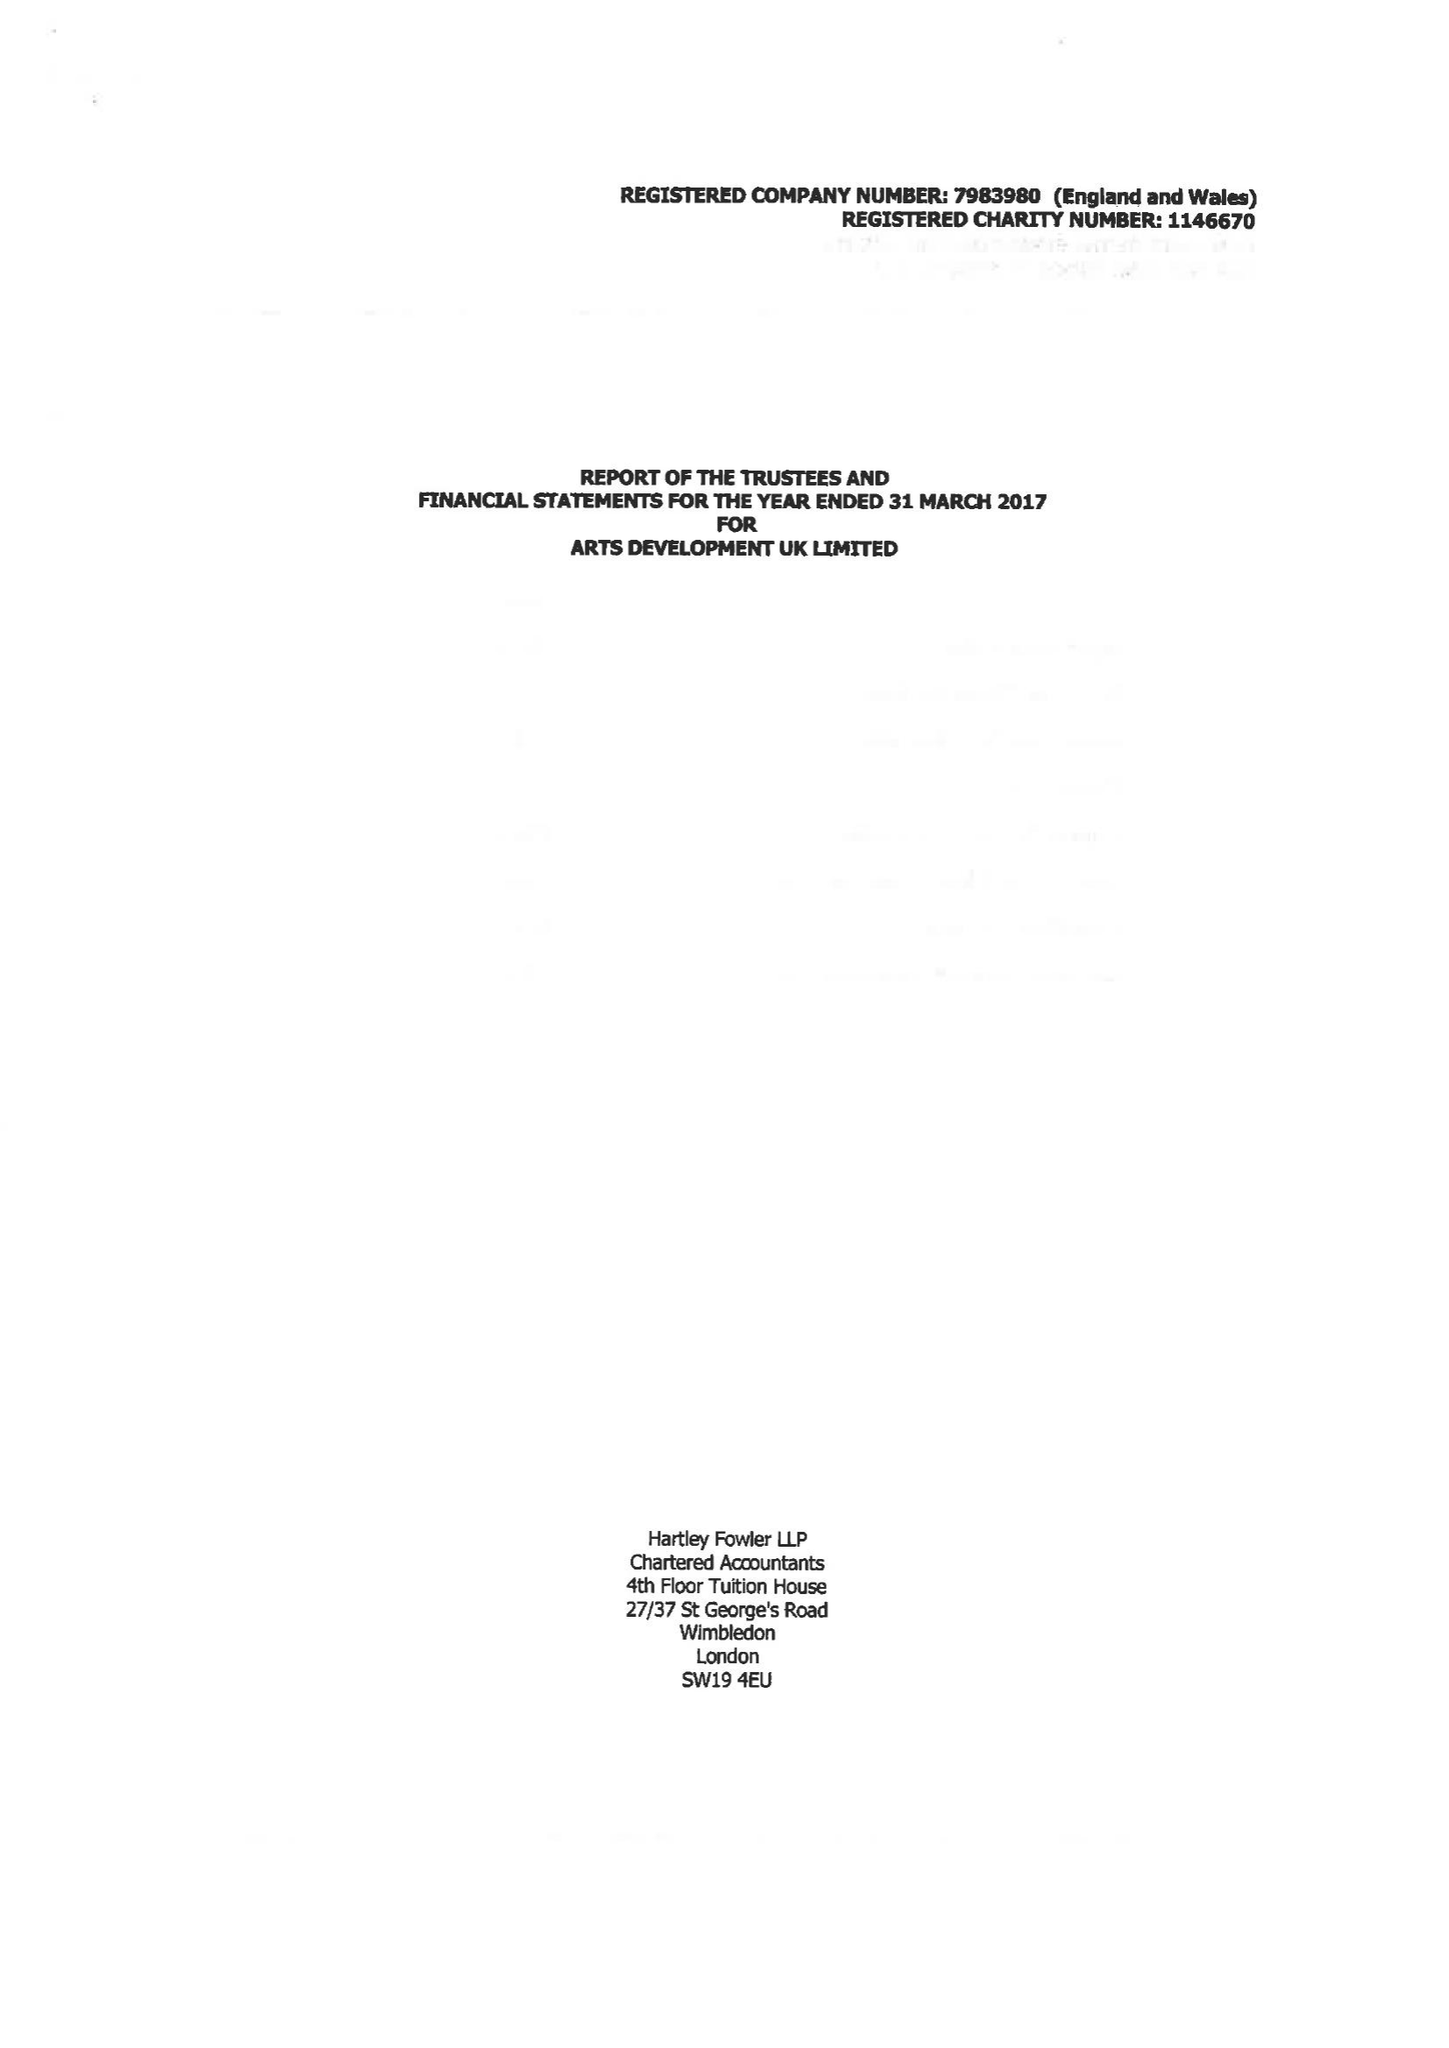What is the value for the report_date?
Answer the question using a single word or phrase. 2017-03-31 